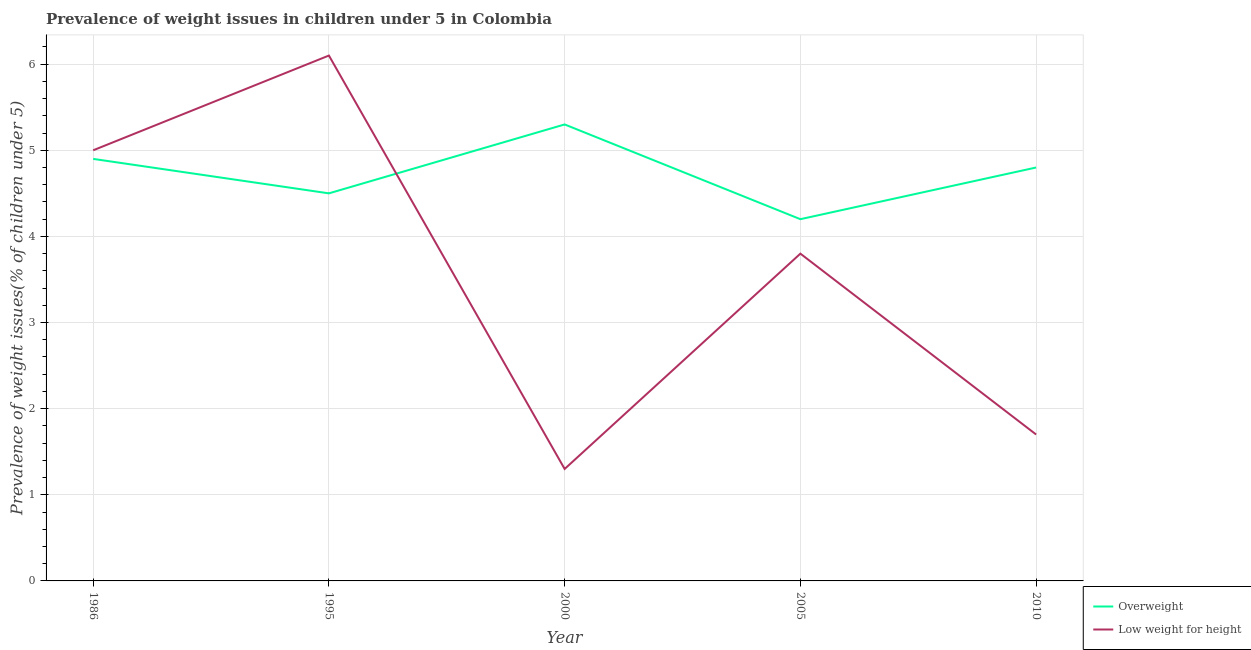How many different coloured lines are there?
Your response must be concise. 2. Does the line corresponding to percentage of overweight children intersect with the line corresponding to percentage of underweight children?
Your response must be concise. Yes. Is the number of lines equal to the number of legend labels?
Your answer should be very brief. Yes. What is the percentage of underweight children in 2005?
Provide a short and direct response. 3.8. Across all years, what is the maximum percentage of overweight children?
Your answer should be very brief. 5.3. Across all years, what is the minimum percentage of overweight children?
Provide a succinct answer. 4.2. In which year was the percentage of overweight children maximum?
Your answer should be compact. 2000. What is the total percentage of underweight children in the graph?
Your response must be concise. 17.9. What is the difference between the percentage of overweight children in 1986 and that in 2010?
Provide a succinct answer. 0.1. What is the difference between the percentage of underweight children in 1986 and the percentage of overweight children in 2000?
Your response must be concise. -0.3. What is the average percentage of overweight children per year?
Your answer should be compact. 4.74. In the year 2000, what is the difference between the percentage of overweight children and percentage of underweight children?
Keep it short and to the point. 4. In how many years, is the percentage of overweight children greater than 1.4 %?
Keep it short and to the point. 5. What is the ratio of the percentage of underweight children in 1995 to that in 2010?
Provide a succinct answer. 3.59. Is the percentage of underweight children in 1995 less than that in 2005?
Your answer should be very brief. No. What is the difference between the highest and the second highest percentage of overweight children?
Offer a terse response. 0.4. What is the difference between the highest and the lowest percentage of overweight children?
Provide a short and direct response. 1.1. In how many years, is the percentage of overweight children greater than the average percentage of overweight children taken over all years?
Your response must be concise. 3. Is the percentage of overweight children strictly greater than the percentage of underweight children over the years?
Offer a terse response. No. Is the percentage of overweight children strictly less than the percentage of underweight children over the years?
Give a very brief answer. No. How many lines are there?
Provide a succinct answer. 2. How many legend labels are there?
Make the answer very short. 2. What is the title of the graph?
Provide a short and direct response. Prevalence of weight issues in children under 5 in Colombia. What is the label or title of the Y-axis?
Ensure brevity in your answer.  Prevalence of weight issues(% of children under 5). What is the Prevalence of weight issues(% of children under 5) of Overweight in 1986?
Provide a succinct answer. 4.9. What is the Prevalence of weight issues(% of children under 5) of Low weight for height in 1995?
Your response must be concise. 6.1. What is the Prevalence of weight issues(% of children under 5) of Overweight in 2000?
Offer a terse response. 5.3. What is the Prevalence of weight issues(% of children under 5) of Low weight for height in 2000?
Your response must be concise. 1.3. What is the Prevalence of weight issues(% of children under 5) of Overweight in 2005?
Your response must be concise. 4.2. What is the Prevalence of weight issues(% of children under 5) of Low weight for height in 2005?
Ensure brevity in your answer.  3.8. What is the Prevalence of weight issues(% of children under 5) in Overweight in 2010?
Your answer should be very brief. 4.8. What is the Prevalence of weight issues(% of children under 5) in Low weight for height in 2010?
Keep it short and to the point. 1.7. Across all years, what is the maximum Prevalence of weight issues(% of children under 5) of Overweight?
Your answer should be compact. 5.3. Across all years, what is the maximum Prevalence of weight issues(% of children under 5) in Low weight for height?
Make the answer very short. 6.1. Across all years, what is the minimum Prevalence of weight issues(% of children under 5) in Overweight?
Your answer should be very brief. 4.2. Across all years, what is the minimum Prevalence of weight issues(% of children under 5) in Low weight for height?
Offer a terse response. 1.3. What is the total Prevalence of weight issues(% of children under 5) in Overweight in the graph?
Offer a very short reply. 23.7. What is the difference between the Prevalence of weight issues(% of children under 5) in Overweight in 1986 and that in 1995?
Your response must be concise. 0.4. What is the difference between the Prevalence of weight issues(% of children under 5) of Low weight for height in 1986 and that in 1995?
Offer a terse response. -1.1. What is the difference between the Prevalence of weight issues(% of children under 5) of Overweight in 1986 and that in 2000?
Offer a very short reply. -0.4. What is the difference between the Prevalence of weight issues(% of children under 5) in Low weight for height in 1986 and that in 2000?
Offer a terse response. 3.7. What is the difference between the Prevalence of weight issues(% of children under 5) in Overweight in 1986 and that in 2005?
Make the answer very short. 0.7. What is the difference between the Prevalence of weight issues(% of children under 5) in Low weight for height in 1986 and that in 2005?
Your answer should be compact. 1.2. What is the difference between the Prevalence of weight issues(% of children under 5) of Low weight for height in 1995 and that in 2000?
Your response must be concise. 4.8. What is the difference between the Prevalence of weight issues(% of children under 5) of Low weight for height in 1995 and that in 2005?
Your response must be concise. 2.3. What is the difference between the Prevalence of weight issues(% of children under 5) of Overweight in 1995 and that in 2010?
Offer a terse response. -0.3. What is the difference between the Prevalence of weight issues(% of children under 5) of Low weight for height in 1995 and that in 2010?
Keep it short and to the point. 4.4. What is the difference between the Prevalence of weight issues(% of children under 5) in Overweight in 2000 and that in 2005?
Provide a short and direct response. 1.1. What is the difference between the Prevalence of weight issues(% of children under 5) of Low weight for height in 2000 and that in 2005?
Your answer should be compact. -2.5. What is the difference between the Prevalence of weight issues(% of children under 5) of Overweight in 2005 and that in 2010?
Provide a succinct answer. -0.6. What is the difference between the Prevalence of weight issues(% of children under 5) of Low weight for height in 2005 and that in 2010?
Your answer should be very brief. 2.1. What is the difference between the Prevalence of weight issues(% of children under 5) in Overweight in 1986 and the Prevalence of weight issues(% of children under 5) in Low weight for height in 1995?
Keep it short and to the point. -1.2. What is the difference between the Prevalence of weight issues(% of children under 5) of Overweight in 1986 and the Prevalence of weight issues(% of children under 5) of Low weight for height in 2000?
Offer a very short reply. 3.6. What is the difference between the Prevalence of weight issues(% of children under 5) of Overweight in 1986 and the Prevalence of weight issues(% of children under 5) of Low weight for height in 2005?
Provide a short and direct response. 1.1. What is the difference between the Prevalence of weight issues(% of children under 5) in Overweight in 1986 and the Prevalence of weight issues(% of children under 5) in Low weight for height in 2010?
Your answer should be compact. 3.2. What is the difference between the Prevalence of weight issues(% of children under 5) in Overweight in 1995 and the Prevalence of weight issues(% of children under 5) in Low weight for height in 2010?
Your answer should be very brief. 2.8. What is the difference between the Prevalence of weight issues(% of children under 5) in Overweight in 2000 and the Prevalence of weight issues(% of children under 5) in Low weight for height in 2010?
Your response must be concise. 3.6. What is the difference between the Prevalence of weight issues(% of children under 5) in Overweight in 2005 and the Prevalence of weight issues(% of children under 5) in Low weight for height in 2010?
Keep it short and to the point. 2.5. What is the average Prevalence of weight issues(% of children under 5) of Overweight per year?
Keep it short and to the point. 4.74. What is the average Prevalence of weight issues(% of children under 5) in Low weight for height per year?
Offer a very short reply. 3.58. In the year 1995, what is the difference between the Prevalence of weight issues(% of children under 5) of Overweight and Prevalence of weight issues(% of children under 5) of Low weight for height?
Offer a very short reply. -1.6. What is the ratio of the Prevalence of weight issues(% of children under 5) of Overweight in 1986 to that in 1995?
Give a very brief answer. 1.09. What is the ratio of the Prevalence of weight issues(% of children under 5) in Low weight for height in 1986 to that in 1995?
Provide a succinct answer. 0.82. What is the ratio of the Prevalence of weight issues(% of children under 5) of Overweight in 1986 to that in 2000?
Your answer should be very brief. 0.92. What is the ratio of the Prevalence of weight issues(% of children under 5) of Low weight for height in 1986 to that in 2000?
Offer a very short reply. 3.85. What is the ratio of the Prevalence of weight issues(% of children under 5) of Low weight for height in 1986 to that in 2005?
Your answer should be very brief. 1.32. What is the ratio of the Prevalence of weight issues(% of children under 5) in Overweight in 1986 to that in 2010?
Ensure brevity in your answer.  1.02. What is the ratio of the Prevalence of weight issues(% of children under 5) in Low weight for height in 1986 to that in 2010?
Provide a short and direct response. 2.94. What is the ratio of the Prevalence of weight issues(% of children under 5) in Overweight in 1995 to that in 2000?
Make the answer very short. 0.85. What is the ratio of the Prevalence of weight issues(% of children under 5) of Low weight for height in 1995 to that in 2000?
Offer a very short reply. 4.69. What is the ratio of the Prevalence of weight issues(% of children under 5) in Overweight in 1995 to that in 2005?
Make the answer very short. 1.07. What is the ratio of the Prevalence of weight issues(% of children under 5) of Low weight for height in 1995 to that in 2005?
Keep it short and to the point. 1.61. What is the ratio of the Prevalence of weight issues(% of children under 5) in Overweight in 1995 to that in 2010?
Offer a very short reply. 0.94. What is the ratio of the Prevalence of weight issues(% of children under 5) of Low weight for height in 1995 to that in 2010?
Provide a succinct answer. 3.59. What is the ratio of the Prevalence of weight issues(% of children under 5) in Overweight in 2000 to that in 2005?
Offer a terse response. 1.26. What is the ratio of the Prevalence of weight issues(% of children under 5) in Low weight for height in 2000 to that in 2005?
Keep it short and to the point. 0.34. What is the ratio of the Prevalence of weight issues(% of children under 5) in Overweight in 2000 to that in 2010?
Your response must be concise. 1.1. What is the ratio of the Prevalence of weight issues(% of children under 5) in Low weight for height in 2000 to that in 2010?
Your answer should be very brief. 0.76. What is the ratio of the Prevalence of weight issues(% of children under 5) in Overweight in 2005 to that in 2010?
Keep it short and to the point. 0.88. What is the ratio of the Prevalence of weight issues(% of children under 5) in Low weight for height in 2005 to that in 2010?
Provide a short and direct response. 2.24. What is the difference between the highest and the second highest Prevalence of weight issues(% of children under 5) in Low weight for height?
Offer a terse response. 1.1. What is the difference between the highest and the lowest Prevalence of weight issues(% of children under 5) in Low weight for height?
Give a very brief answer. 4.8. 